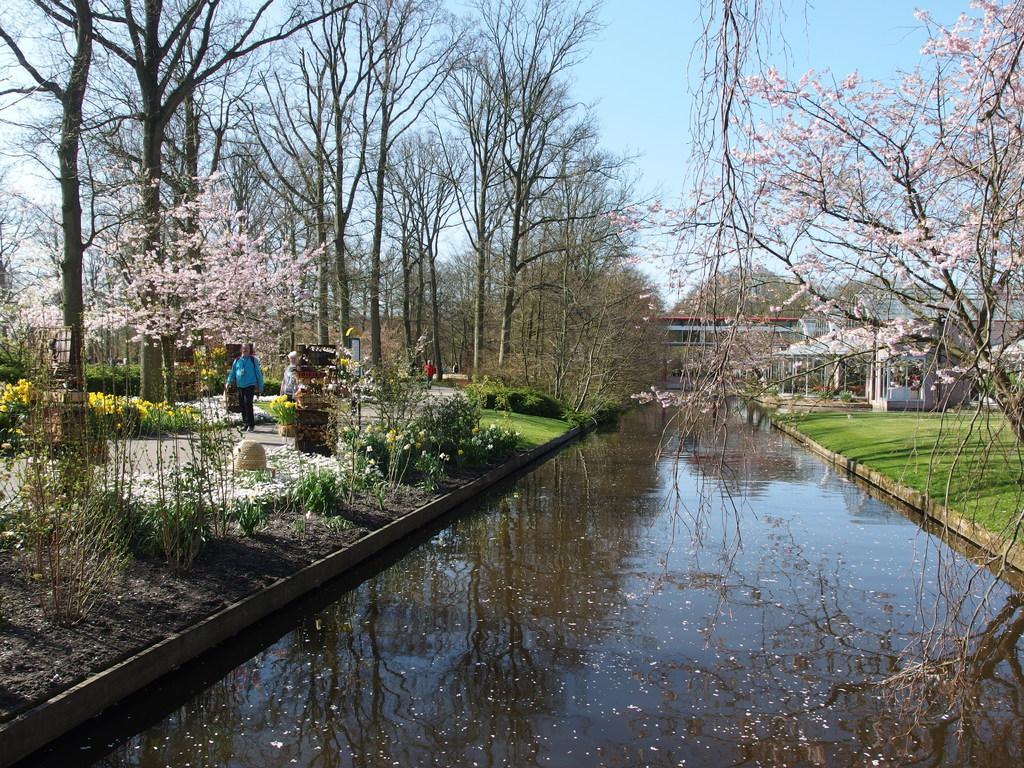In one or two sentences, can you explain what this image depicts? In this picture we can see the grass, water, plants, trees, buildings and a person standing on the ground, some objects and in the background we can see the sky. 